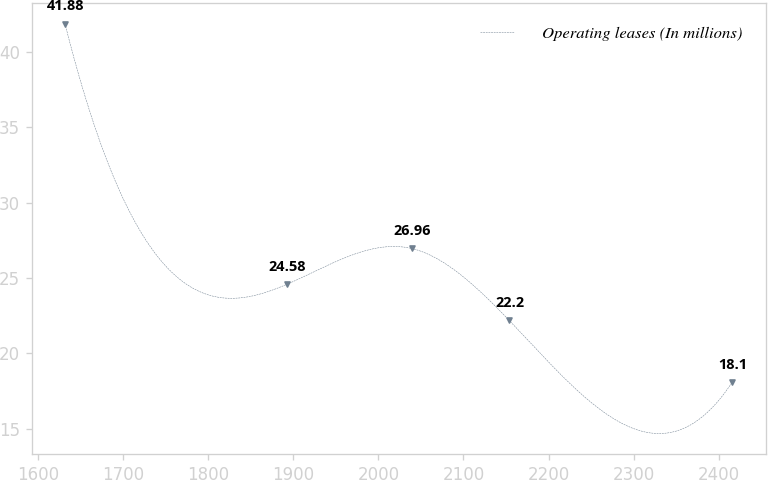Convert chart. <chart><loc_0><loc_0><loc_500><loc_500><line_chart><ecel><fcel>Operating leases (In millions)<nl><fcel>1631.89<fcel>41.88<nl><fcel>1892.48<fcel>24.58<nl><fcel>2039.14<fcel>26.96<nl><fcel>2153.57<fcel>22.2<nl><fcel>2415.84<fcel>18.1<nl></chart> 